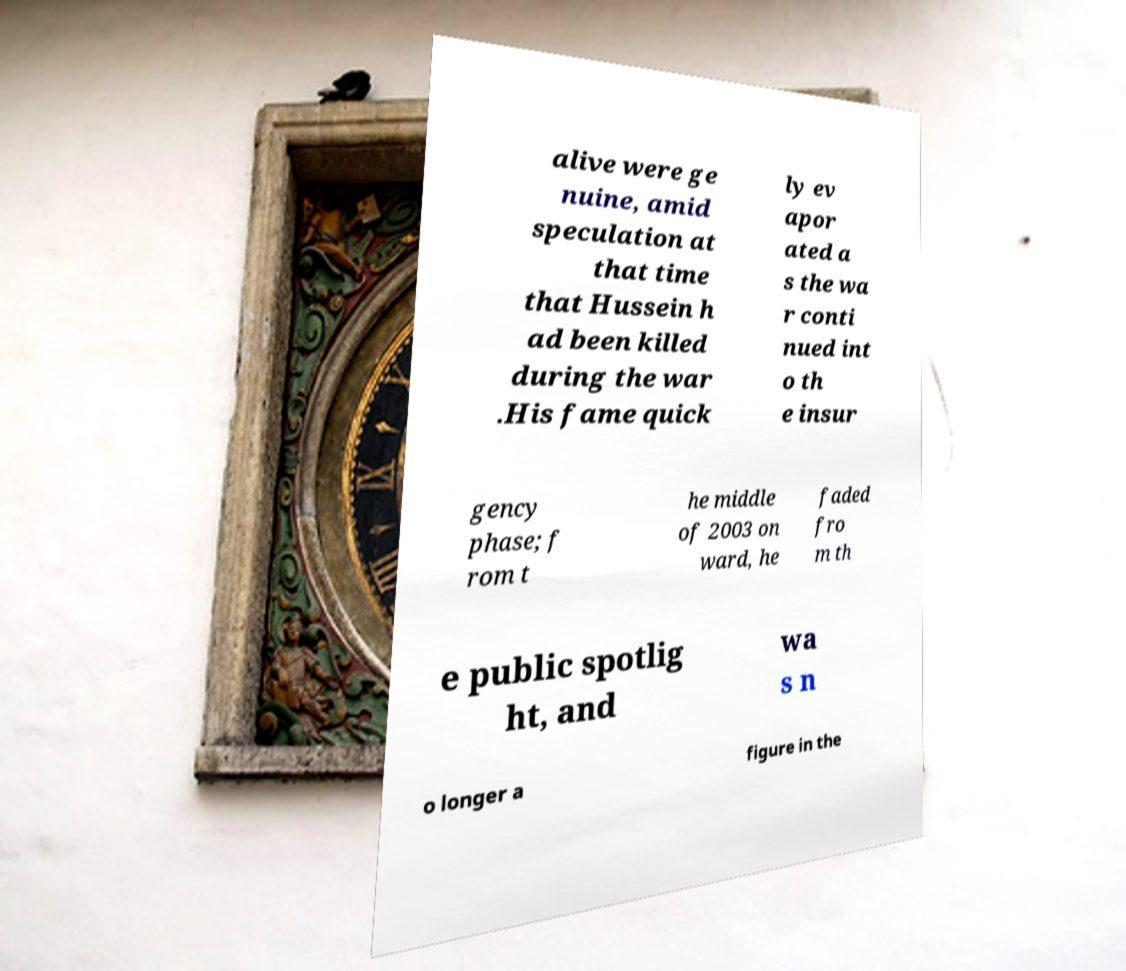Could you assist in decoding the text presented in this image and type it out clearly? alive were ge nuine, amid speculation at that time that Hussein h ad been killed during the war .His fame quick ly ev apor ated a s the wa r conti nued int o th e insur gency phase; f rom t he middle of 2003 on ward, he faded fro m th e public spotlig ht, and wa s n o longer a figure in the 